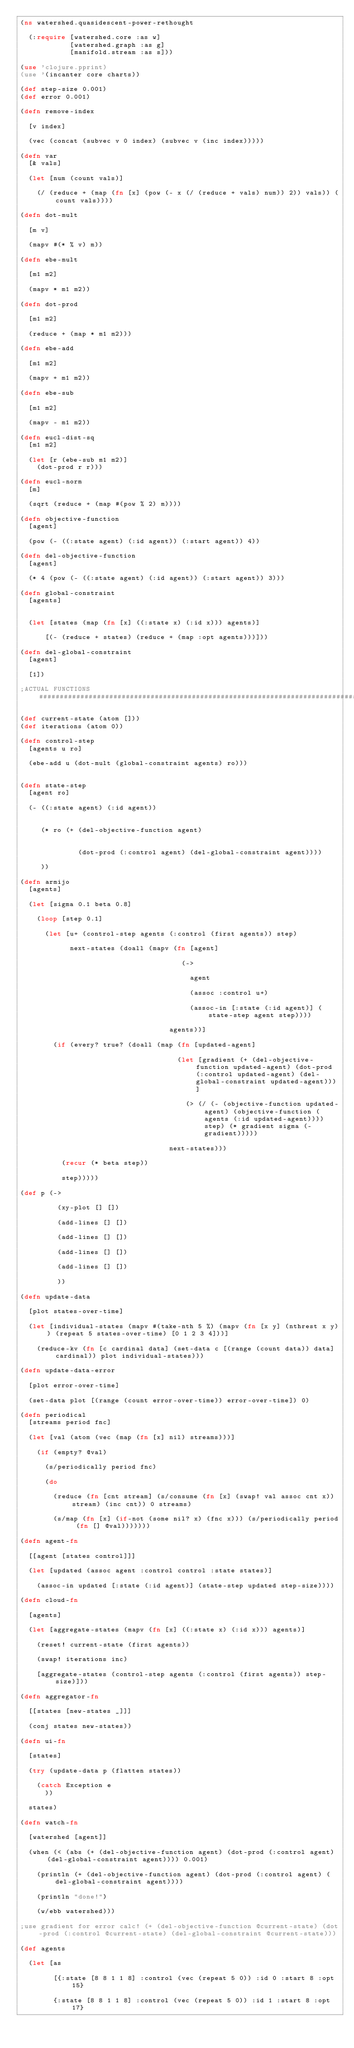<code> <loc_0><loc_0><loc_500><loc_500><_Clojure_>(ns watershed.quasidescent-power-rethought
  
  (:require [watershed.core :as w]
            [watershed.graph :as g]
            [manifold.stream :as s]))

(use 'clojure.pprint)
(use '(incanter core charts))

(def step-size 0.001)
(def error 0.001)

(defn remove-index
  
  [v index] 
  
  (vec (concat (subvec v 0 index) (subvec v (inc index)))))

(defn var 
  [& vals] 
  
  (let [num (count vals)] 
    
    (/ (reduce + (map (fn [x] (pow (- x (/ (reduce + vals) num)) 2)) vals)) (count vals))))

(defn dot-mult
  
  [m v] 
  
  (mapv #(* % v) m))

(defn ebe-mult
  
  [m1 m2]
  
  (mapv * m1 m2))

(defn dot-prod 
  
  [m1 m2]
  
  (reduce + (map * m1 m2)))

(defn ebe-add 
  
  [m1 m2] 
  
  (mapv + m1 m2))

(defn ebe-sub 
  
  [m1 m2]
  
  (mapv - m1 m2))

(defn eucl-dist-sq
  [m1 m2] 
  
  (let [r (ebe-sub m1 m2)] 
    (dot-prod r r)))

(defn eucl-norm 
  [m] 
  
  (sqrt (reduce + (map #(pow % 2) m))))

(defn objective-function 
  [agent] 
  
  (pow (- ((:state agent) (:id agent)) (:start agent)) 4))
  
(defn del-objective-function
  [agent]
  
  (* 4 (pow (- ((:state agent) (:id agent)) (:start agent)) 3)))

(defn global-constraint
  [agents]
  
  
  (let [states (map (fn [x] ((:state x) (:id x))) agents)] 
      
      [(- (reduce + states) (reduce + (map :opt agents)))]))

(defn del-global-constraint 
  [agent]
    
  [1])

;ACTUAL FUNCTIONS####################################################################################

(def current-state (atom []))
(def iterations (atom 0))

(defn control-step 
  [agents u ro] 
  
  (ebe-add u (dot-mult (global-constraint agents) ro)))


(defn state-step
  [agent ro]
  
  (- ((:state agent) (:id agent))
     
     
     (* ro (+ (del-objective-function agent) 
     
     
              (dot-prod (:control agent) (del-global-constraint agent))))
     
     ))

(defn armijo 
  [agents] 
  
  (let [sigma 0.1 beta 0.8]
    
    (loop [step 0.1]
    
      (let [u+ (control-step agents (:control (first agents)) step)
          
            next-states (doall (mapv (fn [agent] 
                             
                                       (-> 
                               
                                         agent 
                                 
                                         (assoc :control u+)
                             
                                         (assoc-in [:state (:id agent)] (state-step agent step)))) 
                         
                                    agents))]
    
        (if (every? true? (doall (map (fn [updated-agent] 
             
                                      (let [gradient (+ (del-objective-function updated-agent) (dot-prod (:control updated-agent) (del-global-constraint updated-agent)))]
             
                                        (> (/ (- (objective-function updated-agent) (objective-function (agents (:id updated-agent)))) step) (* gradient sigma (- gradient)))))
             
                                    next-states)))
          
          (recur (* beta step))
          
          step)))))

(def p (-> 
  
         (xy-plot [] [])
  
         (add-lines [] [])
  
         (add-lines [] [])
  
         (add-lines [] [])
  
         (add-lines [] [])
  
         ))

(defn update-data 
  
  [plot states-over-time]
  
  (let [individual-states (mapv #(take-nth 5 %) (mapv (fn [x y] (nthrest x y)) (repeat 5 states-over-time) [0 1 2 3 4]))]
    
    (reduce-kv (fn [c cardinal data] (set-data c [(range (count data)) data] cardinal)) plot individual-states)))

(defn update-data-error
  
  [plot error-over-time] 
  
  (set-data plot [(range (count error-over-time)) error-over-time]) 0)

(defn periodical
  [streams period fnc]
  
  (let [val (atom (vec (map (fn [x] nil) streams)))]

    (if (empty? @val)

      (s/periodically period fnc)

      (do
        
        (reduce (fn [cnt stream] (s/consume (fn [x] (swap! val assoc cnt x)) stream) (inc cnt)) 0 streams)

        (s/map (fn [x] (if-not (some nil? x) (fnc x))) (s/periodically period (fn [] @val)))))))

(defn agent-fn
  
  [[agent [states control]]]
  
  (let [updated (assoc agent :control control :state states)]
  
    (assoc-in updated [:state (:id agent)] (state-step updated step-size))))

(defn cloud-fn
  
  [agents]     
  
  (let [aggregate-states (mapv (fn [x] ((:state x) (:id x))) agents)]    
    
    (reset! current-state (first agents))
    
    (swap! iterations inc)
  
    [aggregate-states (control-step agents (:control (first agents)) step-size)]))

(defn aggregator-fn 
  
  [[states [new-states _]]]
  
  (conj states new-states))

(defn ui-fn 
  
  [states] 
  
  (try (update-data p (flatten states))
    
    (catch Exception e 
      ))
  
  states)

(defn watch-fn 
  
  [watershed [agent]] 
  
  (when (< (abs (+ (del-objective-function agent) (dot-prod (:control agent) (del-global-constraint agent)))) 0.001)
    
    (println (+ (del-objective-function agent) (dot-prod (:control agent) (del-global-constraint agent))))
    
    (println "done!")
    
    (w/ebb watershed)))

;use gradient for error calc! (+ (del-objective-function @current-state) (dot-prod (:control @current-state) (del-global-constraint @current-state))) 

(def agents 
  
  (let [as
    
        [{:state [8 8 1 1 8] :control (vec (repeat 5 0)) :id 0 :start 8 :opt 15}
  
        {:state [8 8 1 1 8] :control (vec (repeat 5 0)) :id 1 :start 8 :opt 17}
  </code> 